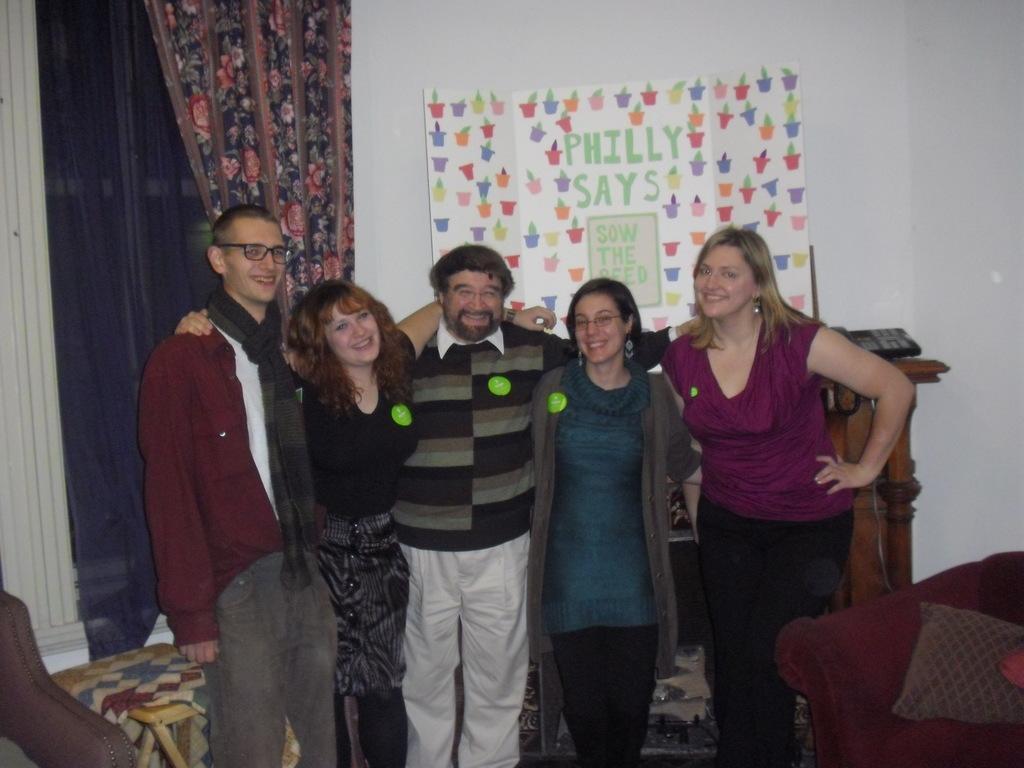Please provide a concise description of this image. This is an inside view. Here I can see three women, two men are standing, smiling and giving pose for the picture. On the right and left sides of the image there are chairs. At the back of the people there is a table. In the background, I can see the wall and also there is a curtain to the wall. To the wall a sheet is attached. 